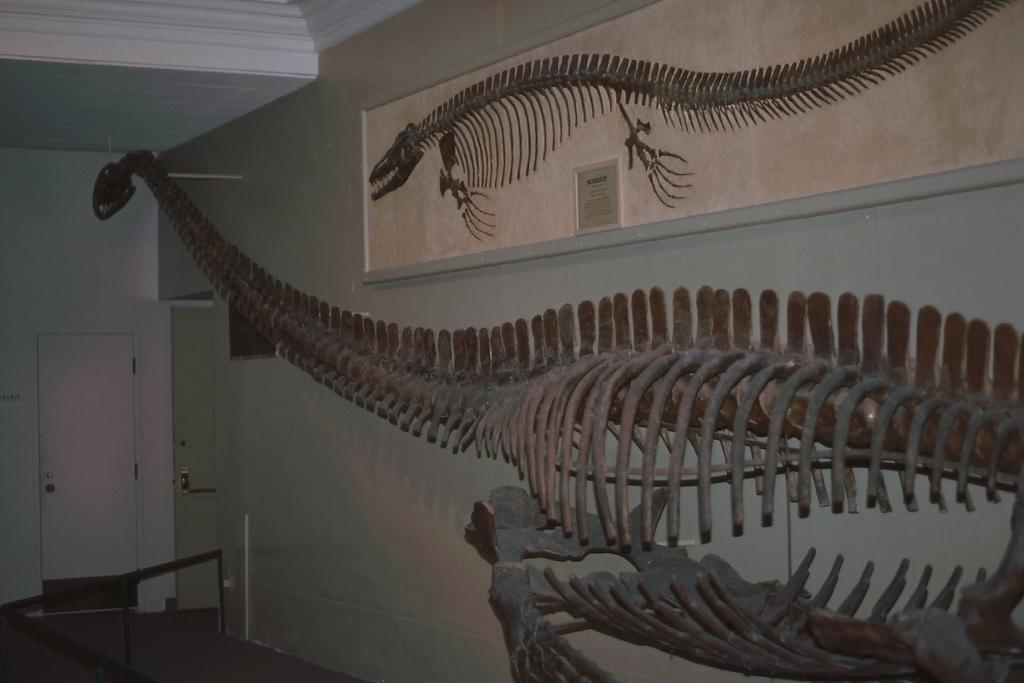In one or two sentences, can you explain what this image depicts? In this image, we can see the skeleton of an animal. We can see some doors and the ground with some objects. We can also see the wall with some objects attached to it. We can also see a board with some text. We can see the roof. 